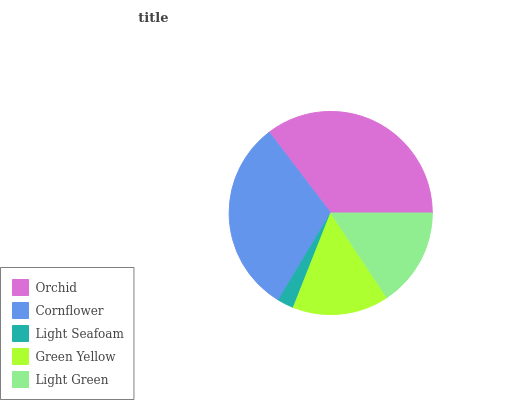Is Light Seafoam the minimum?
Answer yes or no. Yes. Is Orchid the maximum?
Answer yes or no. Yes. Is Cornflower the minimum?
Answer yes or no. No. Is Cornflower the maximum?
Answer yes or no. No. Is Orchid greater than Cornflower?
Answer yes or no. Yes. Is Cornflower less than Orchid?
Answer yes or no. Yes. Is Cornflower greater than Orchid?
Answer yes or no. No. Is Orchid less than Cornflower?
Answer yes or no. No. Is Light Green the high median?
Answer yes or no. Yes. Is Light Green the low median?
Answer yes or no. Yes. Is Orchid the high median?
Answer yes or no. No. Is Orchid the low median?
Answer yes or no. No. 